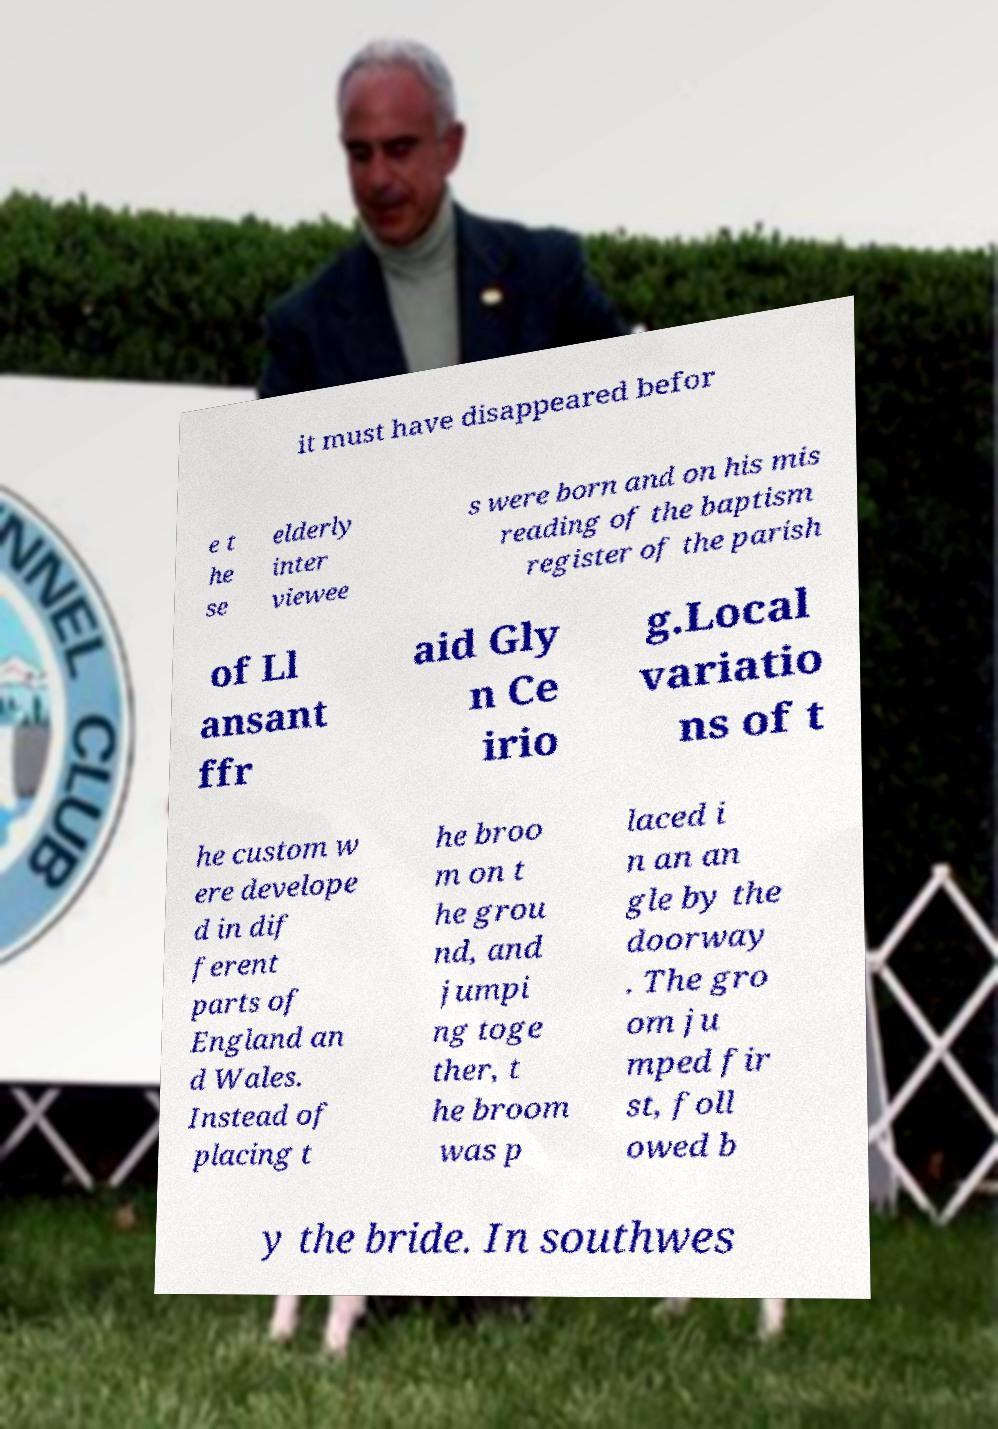Please read and relay the text visible in this image. What does it say? it must have disappeared befor e t he se elderly inter viewee s were born and on his mis reading of the baptism register of the parish of Ll ansant ffr aid Gly n Ce irio g.Local variatio ns of t he custom w ere develope d in dif ferent parts of England an d Wales. Instead of placing t he broo m on t he grou nd, and jumpi ng toge ther, t he broom was p laced i n an an gle by the doorway . The gro om ju mped fir st, foll owed b y the bride. In southwes 